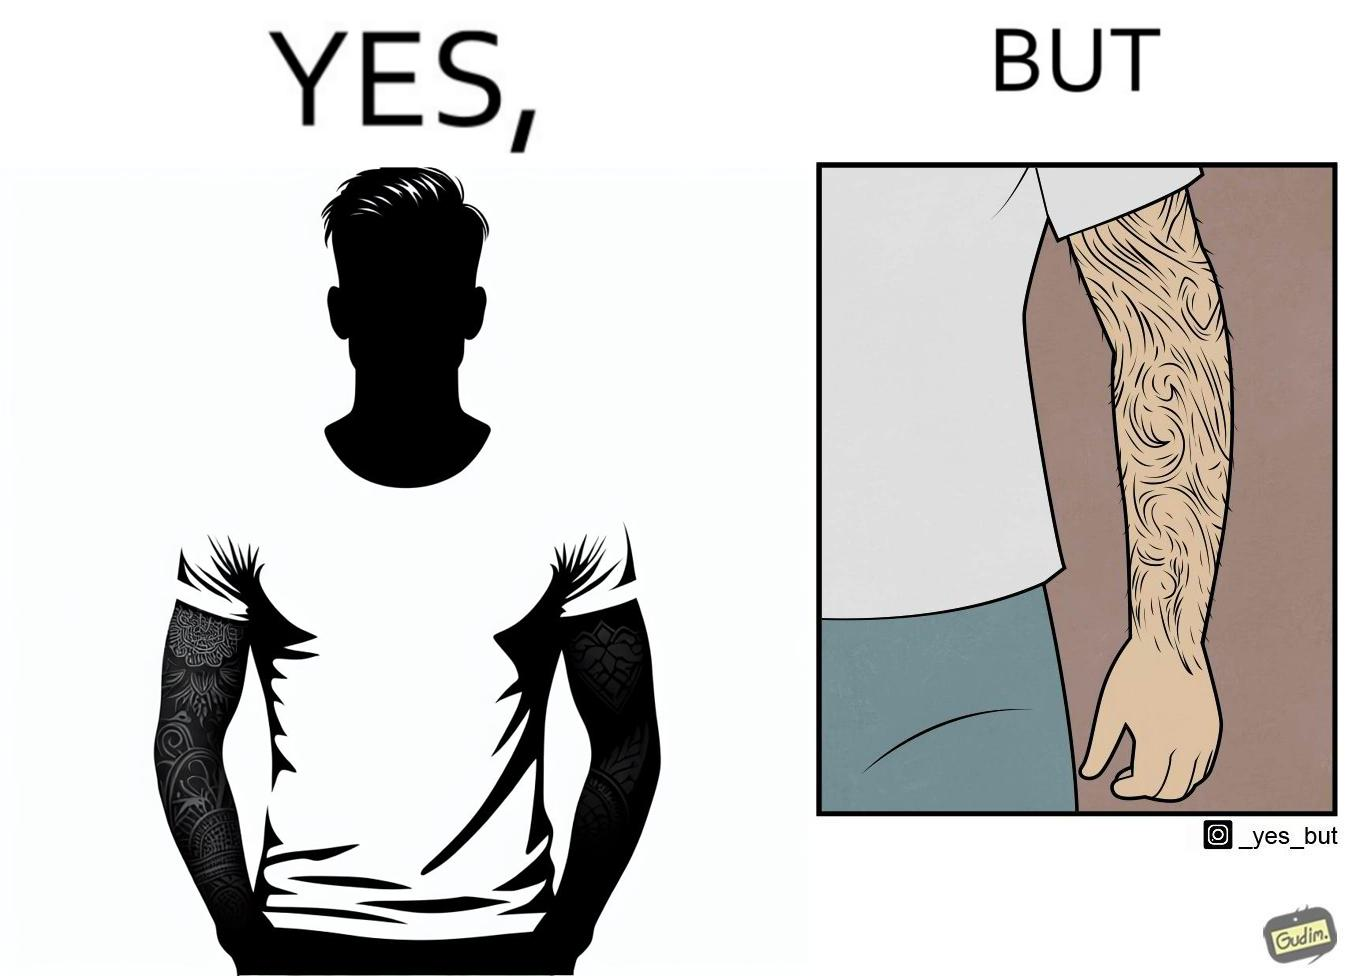Describe what you see in the left and right parts of this image. In the left part of the image: The image shows a man with tattoos on both of his arms. He is wearing white T-shirt . In the right part of the image: The image shows a closeup of an arm. The arm is shown to be very hairy and the hairs are wavy. 